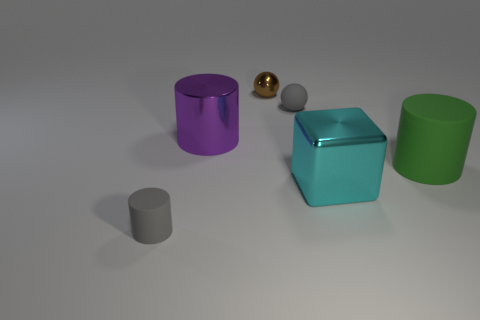What number of cylinders are either small gray objects or large cyan metal things?
Provide a succinct answer. 1. Is there any other thing that has the same material as the small gray ball?
Your answer should be very brief. Yes. There is a cylinder that is on the right side of the gray rubber object that is behind the matte cylinder on the left side of the small rubber ball; what is it made of?
Give a very brief answer. Rubber. There is a small object that is the same color as the rubber sphere; what is it made of?
Keep it short and to the point. Rubber. What number of small brown things are the same material as the cyan cube?
Your answer should be very brief. 1. Is the size of the ball that is in front of the shiny sphere the same as the large cyan metallic object?
Your answer should be compact. No. The cylinder that is the same material as the green object is what color?
Your answer should be compact. Gray. Are there any other things that are the same size as the gray cylinder?
Provide a succinct answer. Yes. There is a block; how many objects are behind it?
Your answer should be very brief. 4. Is the color of the metal thing that is behind the purple metallic thing the same as the small ball on the right side of the tiny brown ball?
Provide a succinct answer. No. 